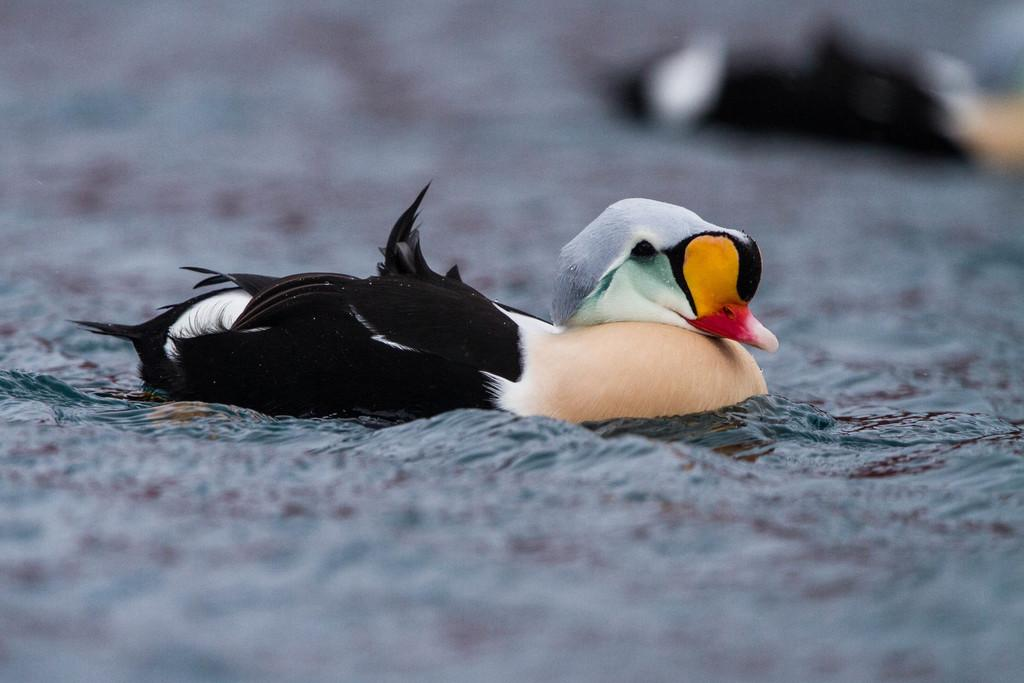What animal is present in the image? There is a duck in the image. Where is the duck located? The duck is in the water. Can you describe the background of the image? The background of the image is blurred. What type of fan is visible in the image? There is no fan present in the image. What kind of structure can be seen in the background of the image? The background of the image is blurred, so it is difficult to discern any specific structures. 